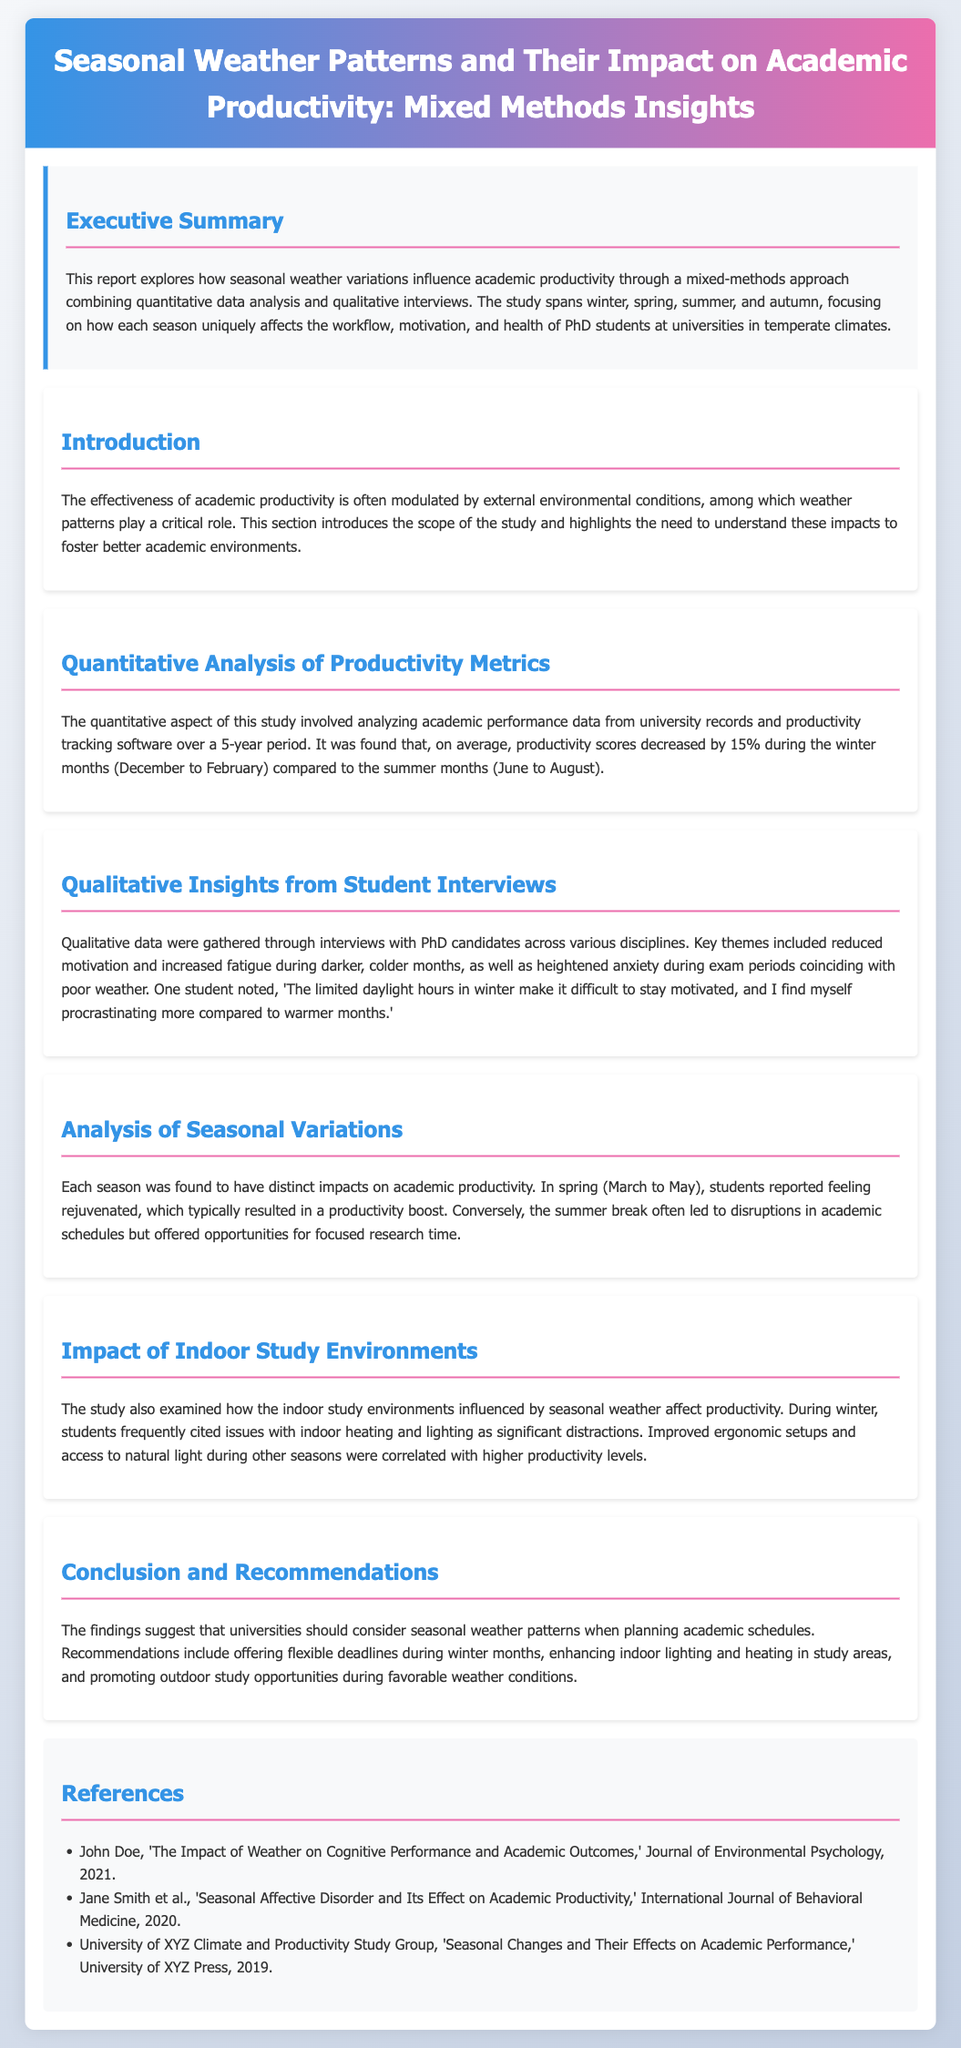What is the average decrease in productivity scores during winter? The document states that productivity scores decreased by 15% during the winter months compared to the summer months.
Answer: 15% What seasons were focused on in the study? The report mentions winter, spring, summer, and autumn as the seasons examined.
Answer: winter, spring, summer, autumn What did students report feeling in spring? The document indicates students reported feeling rejuvenated during spring.
Answer: rejuvenated What significant distraction was cited by students during winter? Students frequently cited issues with indoor heating and lighting as significant distractions during winter.
Answer: indoor heating and lighting What is one recommendation for universities based on the findings? One recommendation is to offer flexible deadlines during winter months based on seasonal impacts on productivity.
Answer: flexible deadlines during winter months How long did the quantitative analysis span? The quantitative analysis involved a period of 5 years according to the document.
Answer: 5 years What profession are the subjects of the study? The study focuses on PhD candidates according to the qualitative insights section.
Answer: PhD candidates What was the notable impact of summer break mentioned? The document notes that the summer break often led to disruptions in academic schedules.
Answer: disruptions in academic schedules What is one theme identified from student interviews? A key theme from student interviews included reduced motivation during colder months.
Answer: reduced motivation during colder months 